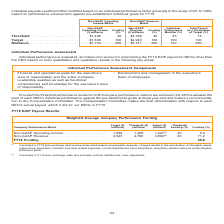According to Nortonlifelock's financial document, What is the target Non-GAAP Revenue? According to the financial document, 4,943 (in millions). The relevant text states: ". $1,428 40 $4,760 40 35 14 Target . $1,630 100 $4,943 100 100 100 Maximum . $1,793 200 $5,141 200 140 280..." Also, What is the FY19 Funding? According to the financial document, 35.6 (percentage). The relevant text states: "ue . 4,943 4,760 4,804 (2) 40 71.2 FY19 Funding . 35.6..." Also, What are the units used for money in this table? According to the financial document, millions. The relevant text states: "ng Revenue Funding Performance as a Percentage ($ millions) (%) ($ millions) (%) Modifier (%) of Target (%) Threshold . $1,428 40 $4,760 40 35 14 Target . $1,..." Also, can you calculate: What is the difference between Actual and Target for Non-GAAP Operating Income? Based on the calculation: 1,630-1,427, the result is 203 (in millions). This is based on the information: "Non-GAAP Operating Income . 1,630 1,428 1,427 (1) 40 0.0 Non-GAAP Revenue . 4,943 4,760 4,804 (2) 40 71.2 FY19 Funding . 35.6 ) Threshold . $1,428 40 $4,760 40 35 14 Target . $1,630 100 $4,943 100 100..." The key data points involved are: 1,427, 1,630. Also, can you calculate: What is the difference between Actual and Target for Non-GAAP Revenue? Based on the calculation: 4,943-4,804, the result is 139 (in millions). This is based on the information: ". $1,428 40 $4,760 40 35 14 Target . $1,630 100 $4,943 100 100 100 Maximum . $1,793 200 $5,141 200 140 280 8 1,427 (1) 40 0.0 Non-GAAP Revenue . 4,943 4,760 4,804 (2) 40 71.2 FY19 Funding . 35.6..." The key data points involved are: 4,804, 4,943. Also, can you calculate: For Non-GAAP Revenue, how much is the target more than the actual in terms of percentages?  To answer this question, I need to perform calculations using the financial data. The calculation is: (4,943-4,804)/4,804, which equals 2.89 (percentage). This is based on the information: ". $1,428 40 $4,760 40 35 14 Target . $1,630 100 $4,943 100 100 100 Maximum . $1,793 200 $5,141 200 140 280 8 1,427 (1) 40 0.0 Non-GAAP Revenue . 4,943 4,760 4,804 (2) 40 71.2 FY19 Funding . 35.6..." The key data points involved are: 4,804, 4,943. 